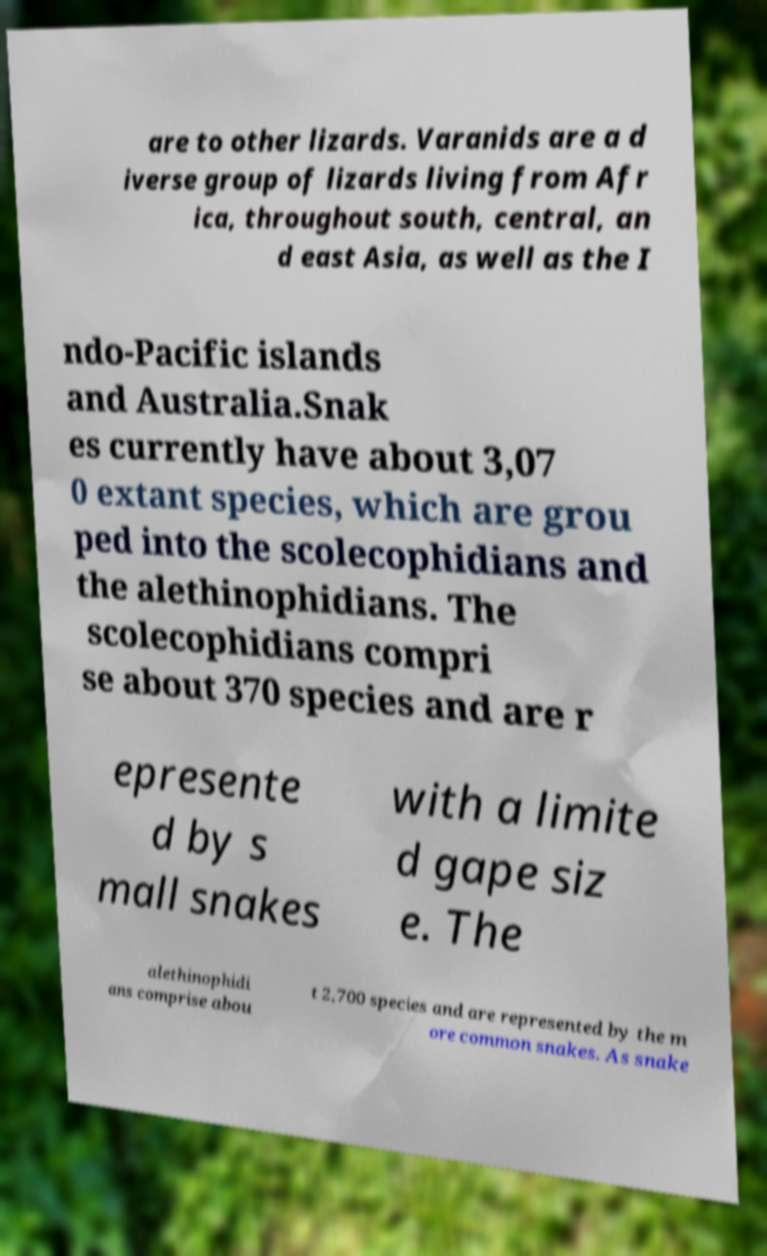Could you assist in decoding the text presented in this image and type it out clearly? are to other lizards. Varanids are a d iverse group of lizards living from Afr ica, throughout south, central, an d east Asia, as well as the I ndo-Pacific islands and Australia.Snak es currently have about 3,07 0 extant species, which are grou ped into the scolecophidians and the alethinophidians. The scolecophidians compri se about 370 species and are r epresente d by s mall snakes with a limite d gape siz e. The alethinophidi ans comprise abou t 2,700 species and are represented by the m ore common snakes. As snake 